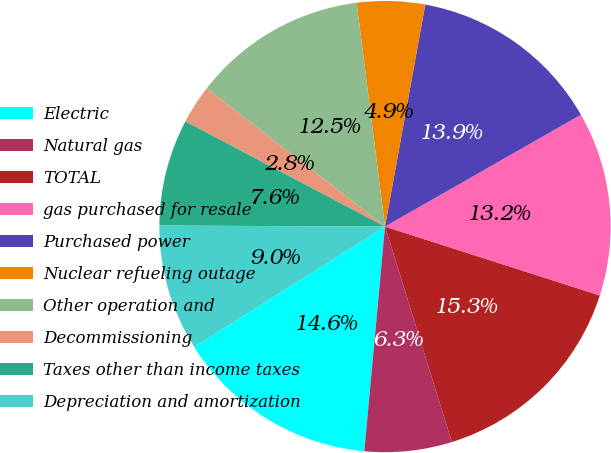Convert chart to OTSL. <chart><loc_0><loc_0><loc_500><loc_500><pie_chart><fcel>Electric<fcel>Natural gas<fcel>TOTAL<fcel>gas purchased for resale<fcel>Purchased power<fcel>Nuclear refueling outage<fcel>Other operation and<fcel>Decommissioning<fcel>Taxes other than income taxes<fcel>Depreciation and amortization<nl><fcel>14.58%<fcel>6.25%<fcel>15.27%<fcel>13.19%<fcel>13.89%<fcel>4.86%<fcel>12.5%<fcel>2.78%<fcel>7.64%<fcel>9.03%<nl></chart> 